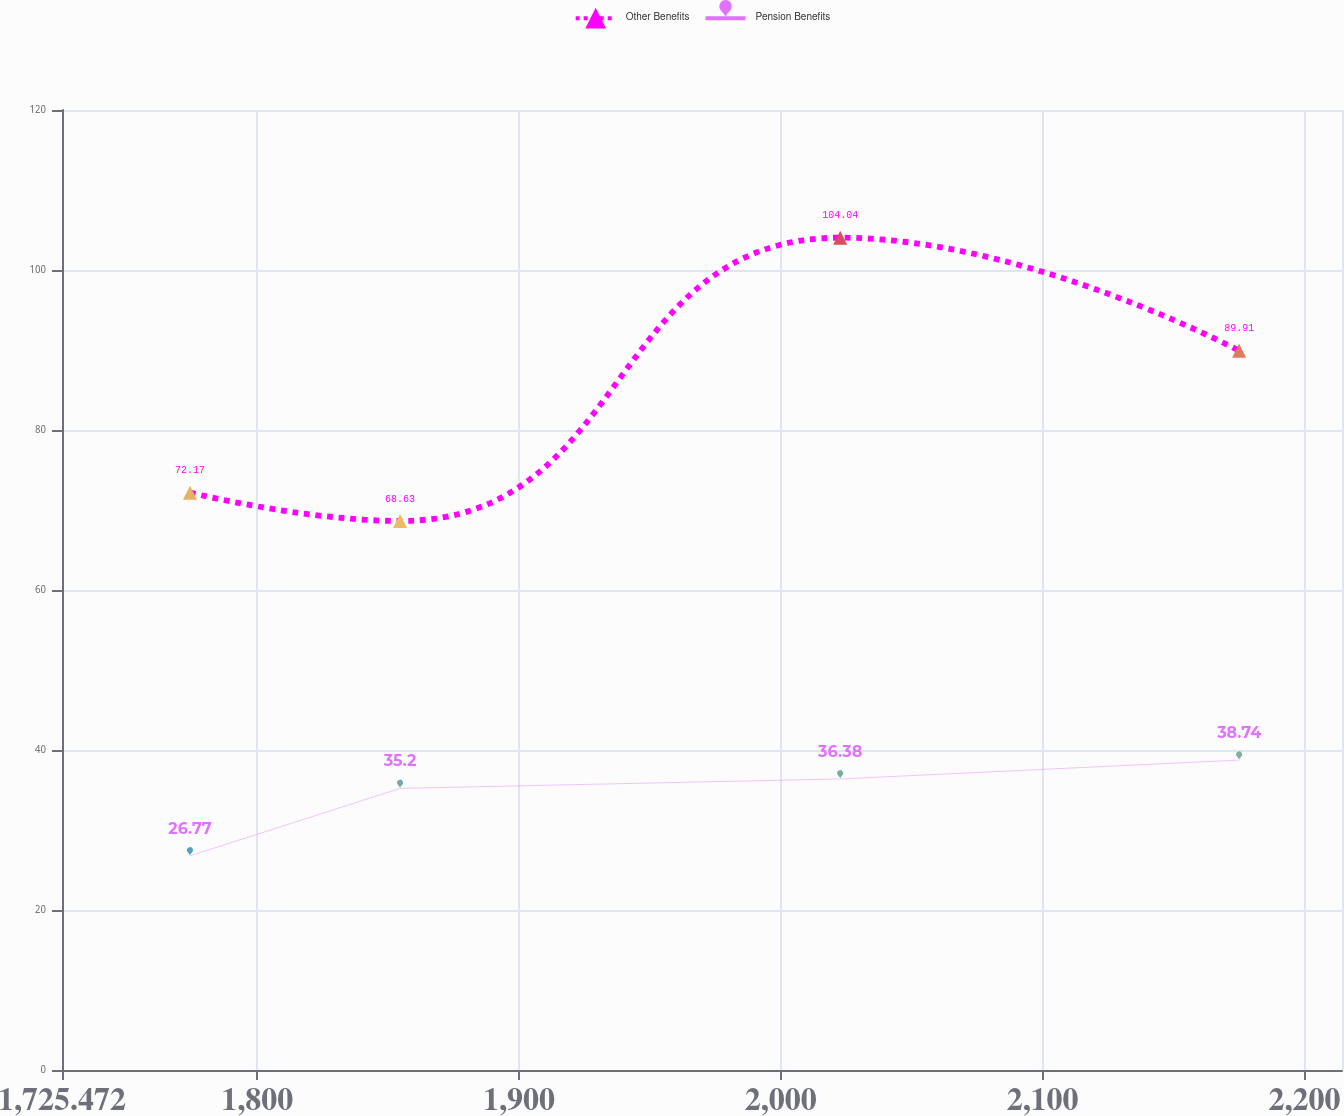Convert chart to OTSL. <chart><loc_0><loc_0><loc_500><loc_500><line_chart><ecel><fcel>Other Benefits<fcel>Pension Benefits<nl><fcel>1774.36<fcel>72.17<fcel>26.77<nl><fcel>1854.59<fcel>68.63<fcel>35.2<nl><fcel>2022.7<fcel>104.04<fcel>36.38<nl><fcel>2175.07<fcel>89.91<fcel>38.74<nl><fcel>2263.24<fcel>96.22<fcel>37.56<nl></chart> 